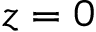<formula> <loc_0><loc_0><loc_500><loc_500>z = 0</formula> 